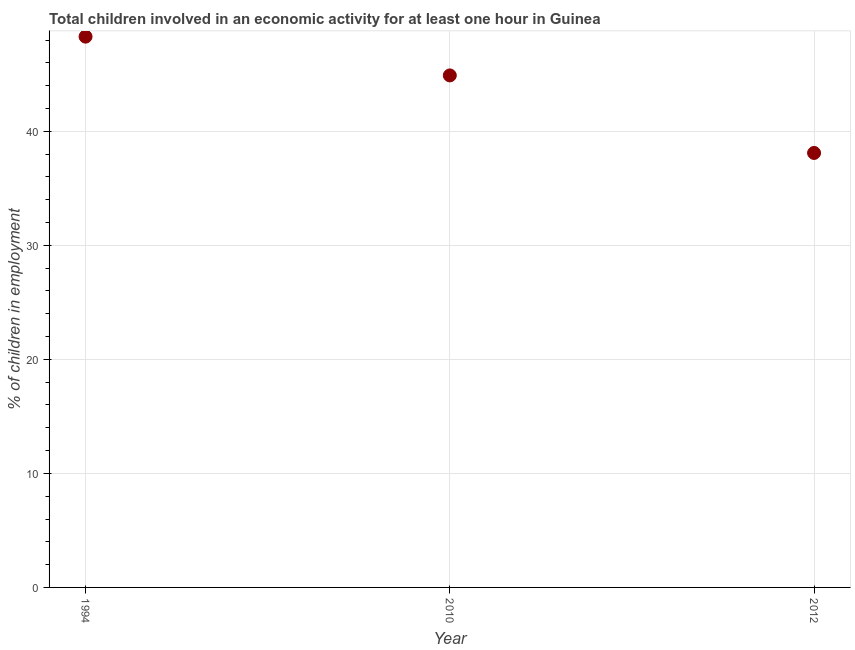What is the percentage of children in employment in 2012?
Provide a short and direct response. 38.1. Across all years, what is the maximum percentage of children in employment?
Offer a terse response. 48.3. Across all years, what is the minimum percentage of children in employment?
Offer a terse response. 38.1. In which year was the percentage of children in employment maximum?
Your answer should be compact. 1994. In which year was the percentage of children in employment minimum?
Your answer should be very brief. 2012. What is the sum of the percentage of children in employment?
Provide a succinct answer. 131.3. What is the difference between the percentage of children in employment in 1994 and 2012?
Make the answer very short. 10.2. What is the average percentage of children in employment per year?
Make the answer very short. 43.77. What is the median percentage of children in employment?
Ensure brevity in your answer.  44.9. In how many years, is the percentage of children in employment greater than 16 %?
Keep it short and to the point. 3. Do a majority of the years between 2010 and 1994 (inclusive) have percentage of children in employment greater than 8 %?
Make the answer very short. No. What is the ratio of the percentage of children in employment in 1994 to that in 2012?
Provide a short and direct response. 1.27. Is the percentage of children in employment in 1994 less than that in 2012?
Make the answer very short. No. What is the difference between the highest and the second highest percentage of children in employment?
Your response must be concise. 3.4. What is the difference between the highest and the lowest percentage of children in employment?
Offer a very short reply. 10.2. Does the percentage of children in employment monotonically increase over the years?
Your response must be concise. No. How many dotlines are there?
Offer a very short reply. 1. Are the values on the major ticks of Y-axis written in scientific E-notation?
Provide a succinct answer. No. Does the graph contain any zero values?
Keep it short and to the point. No. Does the graph contain grids?
Keep it short and to the point. Yes. What is the title of the graph?
Offer a terse response. Total children involved in an economic activity for at least one hour in Guinea. What is the label or title of the X-axis?
Your answer should be compact. Year. What is the label or title of the Y-axis?
Provide a succinct answer. % of children in employment. What is the % of children in employment in 1994?
Your response must be concise. 48.3. What is the % of children in employment in 2010?
Give a very brief answer. 44.9. What is the % of children in employment in 2012?
Keep it short and to the point. 38.1. What is the ratio of the % of children in employment in 1994 to that in 2010?
Make the answer very short. 1.08. What is the ratio of the % of children in employment in 1994 to that in 2012?
Make the answer very short. 1.27. What is the ratio of the % of children in employment in 2010 to that in 2012?
Offer a terse response. 1.18. 